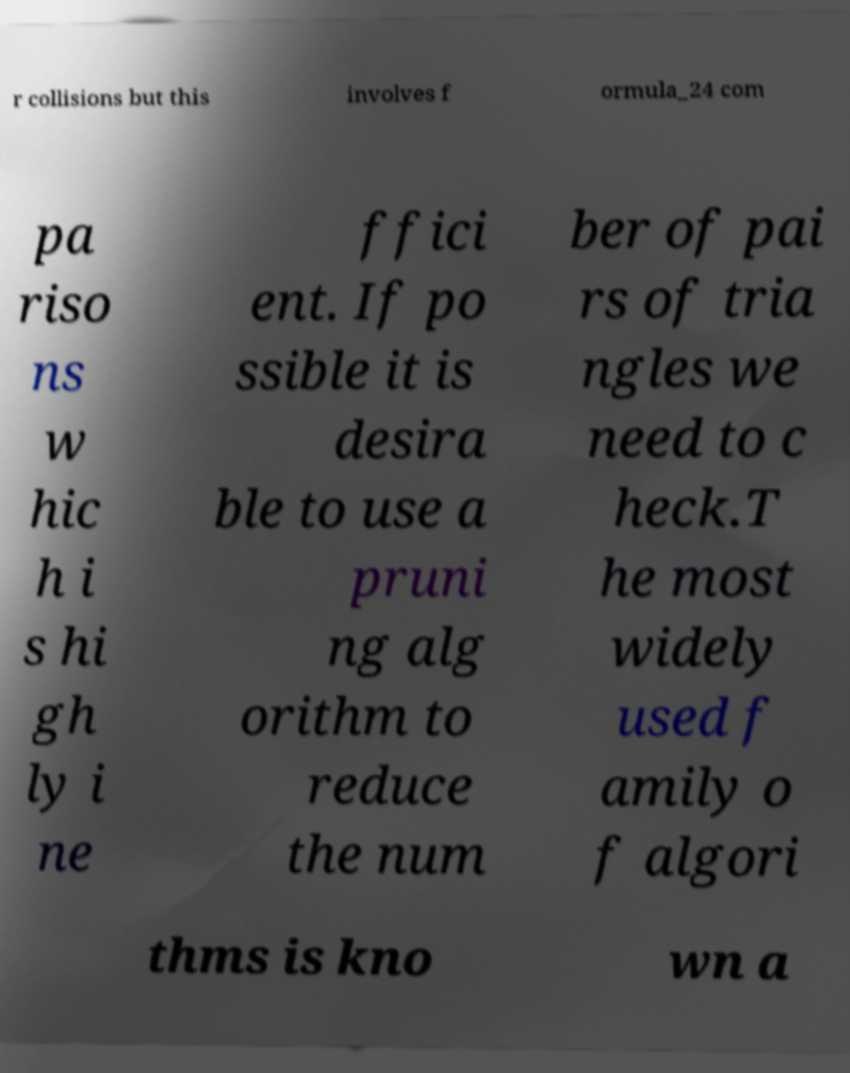Could you assist in decoding the text presented in this image and type it out clearly? r collisions but this involves f ormula_24 com pa riso ns w hic h i s hi gh ly i ne ffici ent. If po ssible it is desira ble to use a pruni ng alg orithm to reduce the num ber of pai rs of tria ngles we need to c heck.T he most widely used f amily o f algori thms is kno wn a 